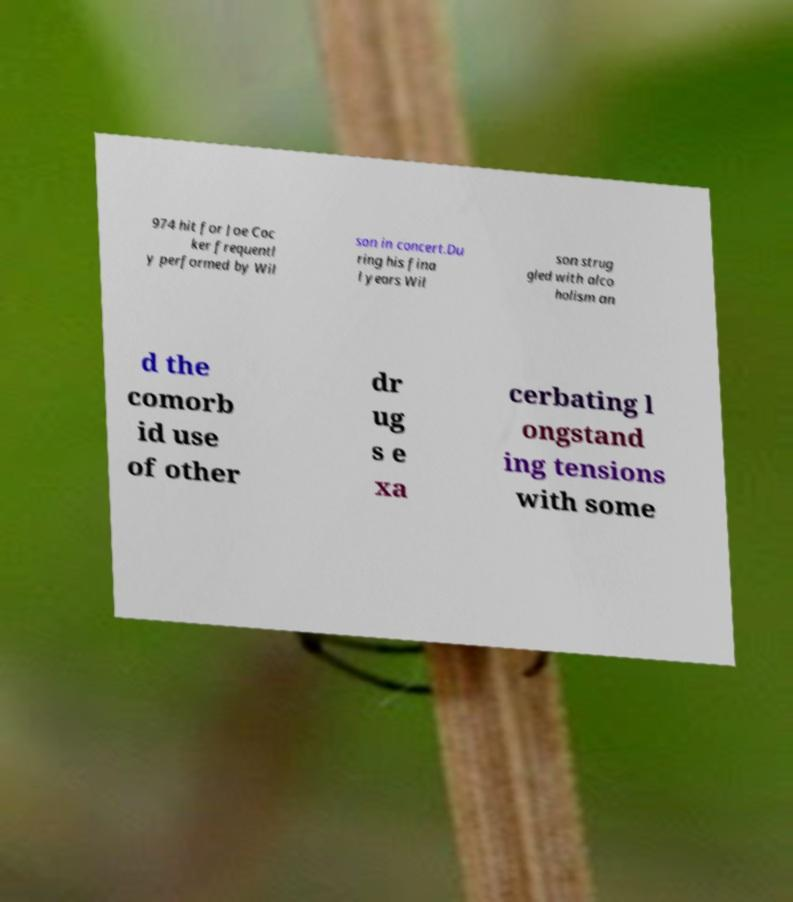For documentation purposes, I need the text within this image transcribed. Could you provide that? 974 hit for Joe Coc ker frequentl y performed by Wil son in concert.Du ring his fina l years Wil son strug gled with alco holism an d the comorb id use of other dr ug s e xa cerbating l ongstand ing tensions with some 